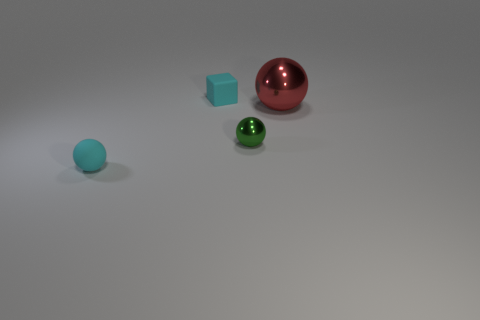There is another small object that is the same shape as the small metal object; what is its material?
Offer a terse response. Rubber. The small ball that is to the right of the cyan cube is what color?
Offer a very short reply. Green. Do the block and the tiny cyan thing in front of the big metallic ball have the same material?
Ensure brevity in your answer.  Yes. What material is the green sphere?
Keep it short and to the point. Metal. What is the shape of the thing that is the same material as the cyan ball?
Provide a succinct answer. Cube. How many other objects are there of the same shape as the small shiny thing?
Provide a succinct answer. 2. There is a green ball; how many large red balls are on the left side of it?
Offer a very short reply. 0. Do the cyan rubber object behind the green shiny thing and the red metal ball behind the small green metal sphere have the same size?
Your answer should be compact. No. How many other objects are the same size as the red sphere?
Make the answer very short. 0. What is the big red object that is in front of the cyan matte thing that is behind the sphere that is left of the cyan cube made of?
Provide a succinct answer. Metal. 